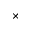Convert formula to latex. <formula><loc_0><loc_0><loc_500><loc_500>\times</formula> 